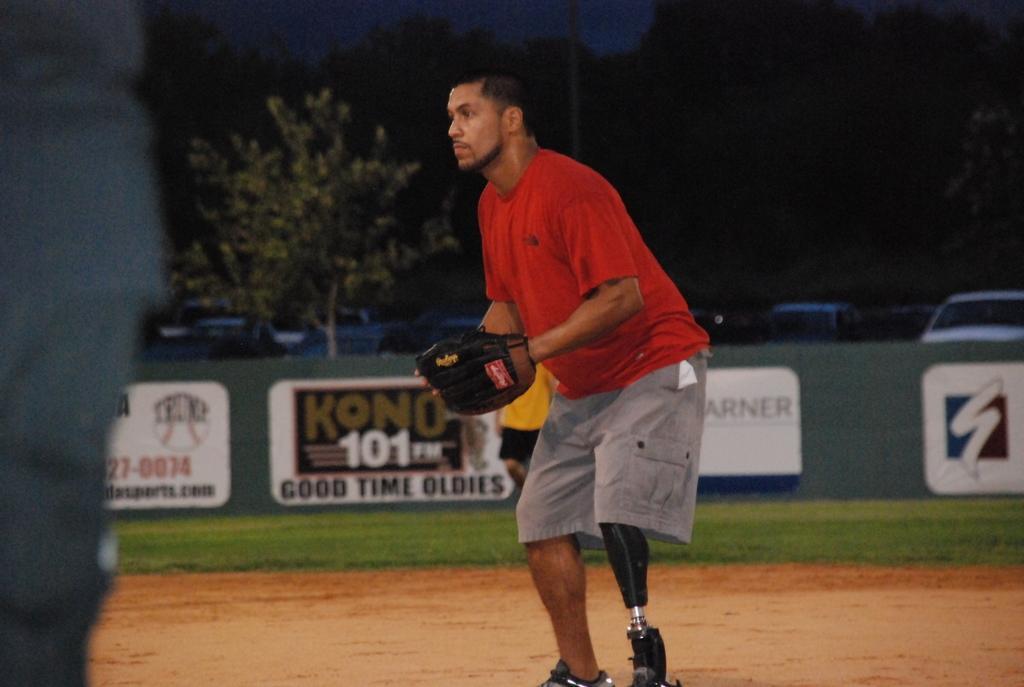Please provide a concise description of this image. In this image I can see a person standing on the ground and wearing gloves and in the background I can see trees , poles and vehicles and I can see a dark view in the background. 